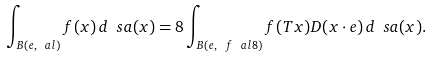<formula> <loc_0><loc_0><loc_500><loc_500>\int _ { B ( e , \ a l ) } f ( x ) \, d \ s a ( x ) = 8 \int _ { B ( e , \ f \ a l 8 ) } f ( T x ) D ( x \cdot e ) \, d \ s a ( x ) .</formula> 